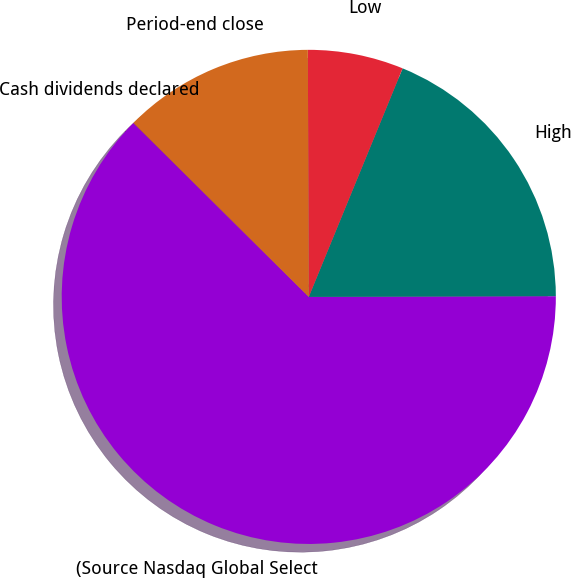Convert chart to OTSL. <chart><loc_0><loc_0><loc_500><loc_500><pie_chart><fcel>(Source Nasdaq Global Select<fcel>High<fcel>Low<fcel>Period-end close<fcel>Cash dividends declared<nl><fcel>62.47%<fcel>18.75%<fcel>6.26%<fcel>12.5%<fcel>0.01%<nl></chart> 